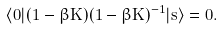<formula> <loc_0><loc_0><loc_500><loc_500>\langle { 0 } | ( 1 - \beta K ) ( 1 - \beta K ) ^ { - 1 } | { s } \rangle = 0 .</formula> 